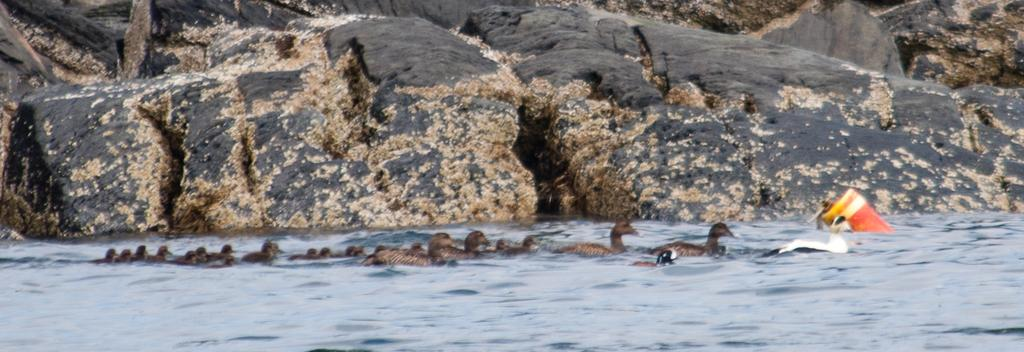What type of natural elements can be seen in the image? There are rocks in the image. What type of animals are present in the image? There are ducks and ducklings in the image. Where are the ducks and ducklings located? The ducks and ducklings are in the water. Can you identify any other objects in the water? Yes, there appears to be a bottle in the water. Can you tell me what type of vase is being used by the judge in the image? There is no vase or judge present in the image. How does the boat affect the movement of the ducks and ducklings in the image? There is no boat present in the image; the ducks and ducklings are in the water without any boat. 